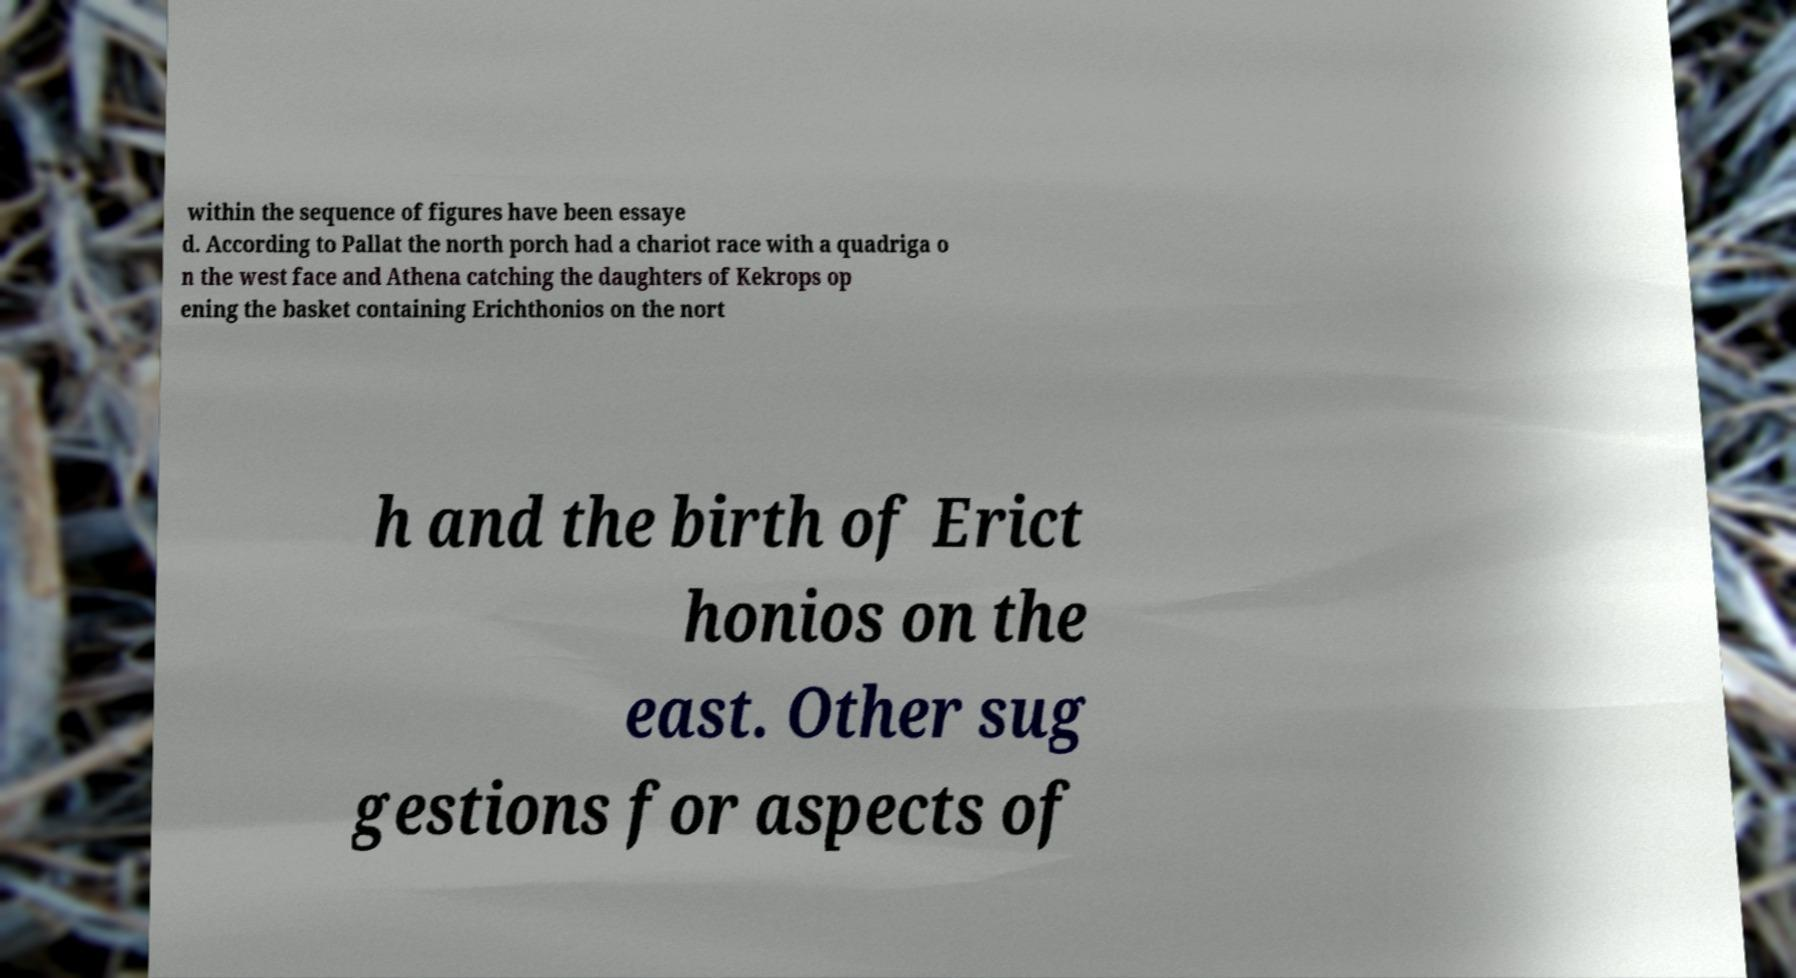I need the written content from this picture converted into text. Can you do that? within the sequence of figures have been essaye d. According to Pallat the north porch had a chariot race with a quadriga o n the west face and Athena catching the daughters of Kekrops op ening the basket containing Erichthonios on the nort h and the birth of Erict honios on the east. Other sug gestions for aspects of 